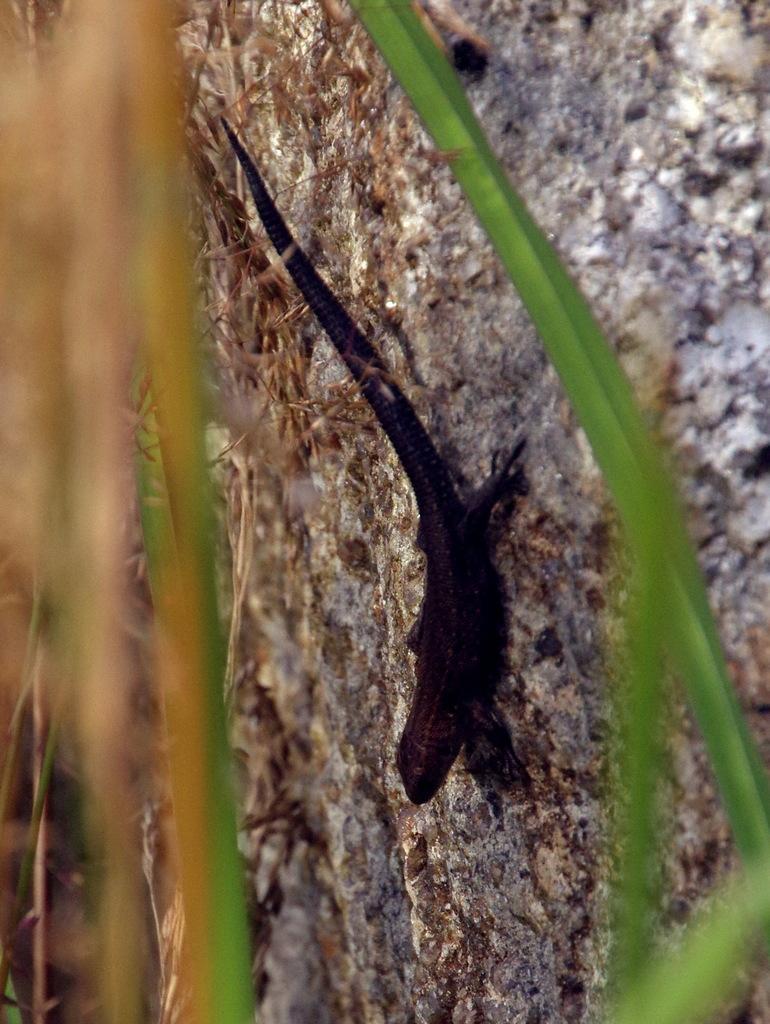Describe this image in one or two sentences. In this image I can see a black color reptile on the grey surface. In front I can see few green leaves. 